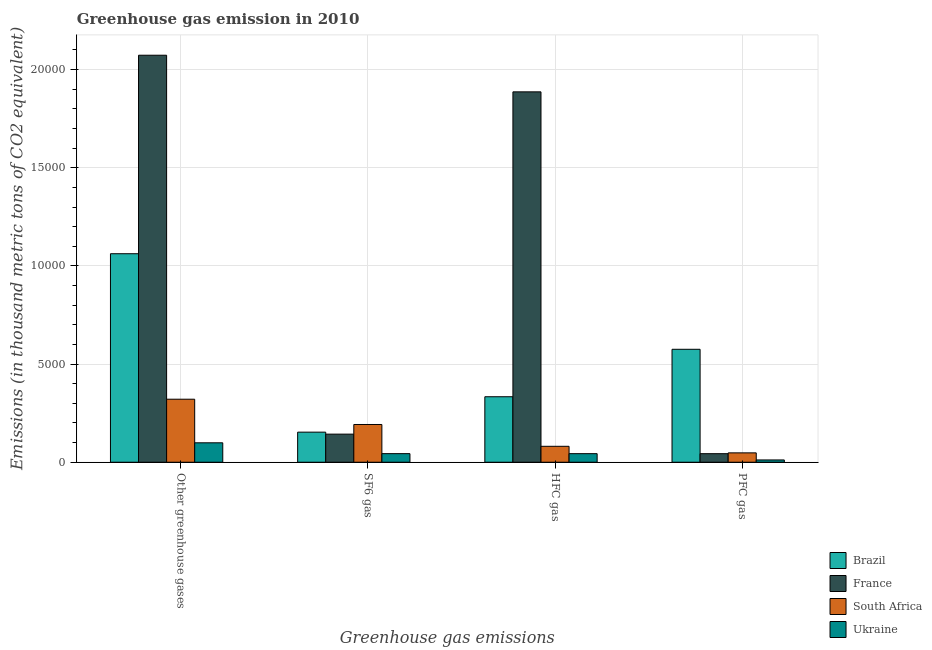How many different coloured bars are there?
Provide a succinct answer. 4. How many groups of bars are there?
Offer a very short reply. 4. Are the number of bars per tick equal to the number of legend labels?
Offer a terse response. Yes. How many bars are there on the 4th tick from the left?
Provide a succinct answer. 4. What is the label of the 2nd group of bars from the left?
Offer a terse response. SF6 gas. What is the emission of greenhouse gases in France?
Give a very brief answer. 2.07e+04. Across all countries, what is the maximum emission of sf6 gas?
Your response must be concise. 1922. Across all countries, what is the minimum emission of sf6 gas?
Your response must be concise. 437. In which country was the emission of hfc gas maximum?
Give a very brief answer. France. In which country was the emission of pfc gas minimum?
Keep it short and to the point. Ukraine. What is the total emission of greenhouse gases in the graph?
Offer a very short reply. 3.56e+04. What is the difference between the emission of pfc gas in France and that in South Africa?
Your answer should be compact. -42. What is the difference between the emission of sf6 gas in Ukraine and the emission of pfc gas in France?
Your response must be concise. 2. What is the average emission of pfc gas per country?
Make the answer very short. 1695.25. What is the difference between the emission of pfc gas and emission of hfc gas in France?
Ensure brevity in your answer.  -1.84e+04. In how many countries, is the emission of hfc gas greater than 17000 thousand metric tons?
Provide a succinct answer. 1. What is the ratio of the emission of hfc gas in France to that in Brazil?
Offer a very short reply. 5.66. Is the difference between the emission of pfc gas in Brazil and South Africa greater than the difference between the emission of greenhouse gases in Brazil and South Africa?
Make the answer very short. No. What is the difference between the highest and the second highest emission of hfc gas?
Your answer should be compact. 1.55e+04. What is the difference between the highest and the lowest emission of sf6 gas?
Give a very brief answer. 1485. In how many countries, is the emission of hfc gas greater than the average emission of hfc gas taken over all countries?
Ensure brevity in your answer.  1. Is the sum of the emission of sf6 gas in France and Brazil greater than the maximum emission of greenhouse gases across all countries?
Provide a short and direct response. No. Is it the case that in every country, the sum of the emission of sf6 gas and emission of pfc gas is greater than the sum of emission of hfc gas and emission of greenhouse gases?
Your answer should be compact. No. What does the 3rd bar from the left in Other greenhouse gases represents?
Give a very brief answer. South Africa. What is the difference between two consecutive major ticks on the Y-axis?
Make the answer very short. 5000. Does the graph contain grids?
Give a very brief answer. Yes. Where does the legend appear in the graph?
Give a very brief answer. Bottom right. How many legend labels are there?
Offer a very short reply. 4. What is the title of the graph?
Your response must be concise. Greenhouse gas emission in 2010. What is the label or title of the X-axis?
Ensure brevity in your answer.  Greenhouse gas emissions. What is the label or title of the Y-axis?
Provide a succinct answer. Emissions (in thousand metric tons of CO2 equivalent). What is the Emissions (in thousand metric tons of CO2 equivalent) of Brazil in Other greenhouse gases?
Give a very brief answer. 1.06e+04. What is the Emissions (in thousand metric tons of CO2 equivalent) in France in Other greenhouse gases?
Make the answer very short. 2.07e+04. What is the Emissions (in thousand metric tons of CO2 equivalent) of South Africa in Other greenhouse gases?
Ensure brevity in your answer.  3210. What is the Emissions (in thousand metric tons of CO2 equivalent) in Ukraine in Other greenhouse gases?
Offer a very short reply. 989. What is the Emissions (in thousand metric tons of CO2 equivalent) of Brazil in SF6 gas?
Provide a short and direct response. 1532. What is the Emissions (in thousand metric tons of CO2 equivalent) of France in SF6 gas?
Ensure brevity in your answer.  1431. What is the Emissions (in thousand metric tons of CO2 equivalent) in South Africa in SF6 gas?
Your answer should be very brief. 1922. What is the Emissions (in thousand metric tons of CO2 equivalent) in Ukraine in SF6 gas?
Give a very brief answer. 437. What is the Emissions (in thousand metric tons of CO2 equivalent) of Brazil in HFC gas?
Ensure brevity in your answer.  3336. What is the Emissions (in thousand metric tons of CO2 equivalent) of France in HFC gas?
Offer a terse response. 1.89e+04. What is the Emissions (in thousand metric tons of CO2 equivalent) of South Africa in HFC gas?
Offer a very short reply. 811. What is the Emissions (in thousand metric tons of CO2 equivalent) of Ukraine in HFC gas?
Give a very brief answer. 436. What is the Emissions (in thousand metric tons of CO2 equivalent) in Brazil in PFC gas?
Keep it short and to the point. 5753. What is the Emissions (in thousand metric tons of CO2 equivalent) of France in PFC gas?
Your answer should be very brief. 435. What is the Emissions (in thousand metric tons of CO2 equivalent) in South Africa in PFC gas?
Ensure brevity in your answer.  477. What is the Emissions (in thousand metric tons of CO2 equivalent) in Ukraine in PFC gas?
Provide a succinct answer. 116. Across all Greenhouse gas emissions, what is the maximum Emissions (in thousand metric tons of CO2 equivalent) of Brazil?
Keep it short and to the point. 1.06e+04. Across all Greenhouse gas emissions, what is the maximum Emissions (in thousand metric tons of CO2 equivalent) in France?
Your response must be concise. 2.07e+04. Across all Greenhouse gas emissions, what is the maximum Emissions (in thousand metric tons of CO2 equivalent) of South Africa?
Your response must be concise. 3210. Across all Greenhouse gas emissions, what is the maximum Emissions (in thousand metric tons of CO2 equivalent) of Ukraine?
Your answer should be compact. 989. Across all Greenhouse gas emissions, what is the minimum Emissions (in thousand metric tons of CO2 equivalent) in Brazil?
Give a very brief answer. 1532. Across all Greenhouse gas emissions, what is the minimum Emissions (in thousand metric tons of CO2 equivalent) in France?
Your response must be concise. 435. Across all Greenhouse gas emissions, what is the minimum Emissions (in thousand metric tons of CO2 equivalent) in South Africa?
Provide a short and direct response. 477. Across all Greenhouse gas emissions, what is the minimum Emissions (in thousand metric tons of CO2 equivalent) in Ukraine?
Your response must be concise. 116. What is the total Emissions (in thousand metric tons of CO2 equivalent) in Brazil in the graph?
Keep it short and to the point. 2.12e+04. What is the total Emissions (in thousand metric tons of CO2 equivalent) of France in the graph?
Provide a short and direct response. 4.15e+04. What is the total Emissions (in thousand metric tons of CO2 equivalent) in South Africa in the graph?
Your response must be concise. 6420. What is the total Emissions (in thousand metric tons of CO2 equivalent) in Ukraine in the graph?
Your response must be concise. 1978. What is the difference between the Emissions (in thousand metric tons of CO2 equivalent) in Brazil in Other greenhouse gases and that in SF6 gas?
Your answer should be compact. 9089. What is the difference between the Emissions (in thousand metric tons of CO2 equivalent) in France in Other greenhouse gases and that in SF6 gas?
Make the answer very short. 1.93e+04. What is the difference between the Emissions (in thousand metric tons of CO2 equivalent) in South Africa in Other greenhouse gases and that in SF6 gas?
Your answer should be compact. 1288. What is the difference between the Emissions (in thousand metric tons of CO2 equivalent) of Ukraine in Other greenhouse gases and that in SF6 gas?
Make the answer very short. 552. What is the difference between the Emissions (in thousand metric tons of CO2 equivalent) of Brazil in Other greenhouse gases and that in HFC gas?
Provide a succinct answer. 7285. What is the difference between the Emissions (in thousand metric tons of CO2 equivalent) of France in Other greenhouse gases and that in HFC gas?
Your response must be concise. 1866. What is the difference between the Emissions (in thousand metric tons of CO2 equivalent) in South Africa in Other greenhouse gases and that in HFC gas?
Give a very brief answer. 2399. What is the difference between the Emissions (in thousand metric tons of CO2 equivalent) in Ukraine in Other greenhouse gases and that in HFC gas?
Your answer should be compact. 553. What is the difference between the Emissions (in thousand metric tons of CO2 equivalent) in Brazil in Other greenhouse gases and that in PFC gas?
Your response must be concise. 4868. What is the difference between the Emissions (in thousand metric tons of CO2 equivalent) of France in Other greenhouse gases and that in PFC gas?
Keep it short and to the point. 2.03e+04. What is the difference between the Emissions (in thousand metric tons of CO2 equivalent) of South Africa in Other greenhouse gases and that in PFC gas?
Provide a succinct answer. 2733. What is the difference between the Emissions (in thousand metric tons of CO2 equivalent) of Ukraine in Other greenhouse gases and that in PFC gas?
Ensure brevity in your answer.  873. What is the difference between the Emissions (in thousand metric tons of CO2 equivalent) in Brazil in SF6 gas and that in HFC gas?
Offer a terse response. -1804. What is the difference between the Emissions (in thousand metric tons of CO2 equivalent) in France in SF6 gas and that in HFC gas?
Ensure brevity in your answer.  -1.74e+04. What is the difference between the Emissions (in thousand metric tons of CO2 equivalent) of South Africa in SF6 gas and that in HFC gas?
Your answer should be very brief. 1111. What is the difference between the Emissions (in thousand metric tons of CO2 equivalent) of Brazil in SF6 gas and that in PFC gas?
Your answer should be compact. -4221. What is the difference between the Emissions (in thousand metric tons of CO2 equivalent) in France in SF6 gas and that in PFC gas?
Your answer should be compact. 996. What is the difference between the Emissions (in thousand metric tons of CO2 equivalent) in South Africa in SF6 gas and that in PFC gas?
Make the answer very short. 1445. What is the difference between the Emissions (in thousand metric tons of CO2 equivalent) of Ukraine in SF6 gas and that in PFC gas?
Offer a very short reply. 321. What is the difference between the Emissions (in thousand metric tons of CO2 equivalent) in Brazil in HFC gas and that in PFC gas?
Offer a very short reply. -2417. What is the difference between the Emissions (in thousand metric tons of CO2 equivalent) in France in HFC gas and that in PFC gas?
Keep it short and to the point. 1.84e+04. What is the difference between the Emissions (in thousand metric tons of CO2 equivalent) of South Africa in HFC gas and that in PFC gas?
Ensure brevity in your answer.  334. What is the difference between the Emissions (in thousand metric tons of CO2 equivalent) of Ukraine in HFC gas and that in PFC gas?
Your answer should be compact. 320. What is the difference between the Emissions (in thousand metric tons of CO2 equivalent) of Brazil in Other greenhouse gases and the Emissions (in thousand metric tons of CO2 equivalent) of France in SF6 gas?
Give a very brief answer. 9190. What is the difference between the Emissions (in thousand metric tons of CO2 equivalent) of Brazil in Other greenhouse gases and the Emissions (in thousand metric tons of CO2 equivalent) of South Africa in SF6 gas?
Provide a succinct answer. 8699. What is the difference between the Emissions (in thousand metric tons of CO2 equivalent) in Brazil in Other greenhouse gases and the Emissions (in thousand metric tons of CO2 equivalent) in Ukraine in SF6 gas?
Give a very brief answer. 1.02e+04. What is the difference between the Emissions (in thousand metric tons of CO2 equivalent) of France in Other greenhouse gases and the Emissions (in thousand metric tons of CO2 equivalent) of South Africa in SF6 gas?
Ensure brevity in your answer.  1.88e+04. What is the difference between the Emissions (in thousand metric tons of CO2 equivalent) of France in Other greenhouse gases and the Emissions (in thousand metric tons of CO2 equivalent) of Ukraine in SF6 gas?
Offer a very short reply. 2.03e+04. What is the difference between the Emissions (in thousand metric tons of CO2 equivalent) in South Africa in Other greenhouse gases and the Emissions (in thousand metric tons of CO2 equivalent) in Ukraine in SF6 gas?
Ensure brevity in your answer.  2773. What is the difference between the Emissions (in thousand metric tons of CO2 equivalent) of Brazil in Other greenhouse gases and the Emissions (in thousand metric tons of CO2 equivalent) of France in HFC gas?
Offer a very short reply. -8246. What is the difference between the Emissions (in thousand metric tons of CO2 equivalent) in Brazil in Other greenhouse gases and the Emissions (in thousand metric tons of CO2 equivalent) in South Africa in HFC gas?
Make the answer very short. 9810. What is the difference between the Emissions (in thousand metric tons of CO2 equivalent) of Brazil in Other greenhouse gases and the Emissions (in thousand metric tons of CO2 equivalent) of Ukraine in HFC gas?
Offer a very short reply. 1.02e+04. What is the difference between the Emissions (in thousand metric tons of CO2 equivalent) in France in Other greenhouse gases and the Emissions (in thousand metric tons of CO2 equivalent) in South Africa in HFC gas?
Make the answer very short. 1.99e+04. What is the difference between the Emissions (in thousand metric tons of CO2 equivalent) of France in Other greenhouse gases and the Emissions (in thousand metric tons of CO2 equivalent) of Ukraine in HFC gas?
Keep it short and to the point. 2.03e+04. What is the difference between the Emissions (in thousand metric tons of CO2 equivalent) in South Africa in Other greenhouse gases and the Emissions (in thousand metric tons of CO2 equivalent) in Ukraine in HFC gas?
Your response must be concise. 2774. What is the difference between the Emissions (in thousand metric tons of CO2 equivalent) of Brazil in Other greenhouse gases and the Emissions (in thousand metric tons of CO2 equivalent) of France in PFC gas?
Offer a terse response. 1.02e+04. What is the difference between the Emissions (in thousand metric tons of CO2 equivalent) in Brazil in Other greenhouse gases and the Emissions (in thousand metric tons of CO2 equivalent) in South Africa in PFC gas?
Make the answer very short. 1.01e+04. What is the difference between the Emissions (in thousand metric tons of CO2 equivalent) in Brazil in Other greenhouse gases and the Emissions (in thousand metric tons of CO2 equivalent) in Ukraine in PFC gas?
Your answer should be compact. 1.05e+04. What is the difference between the Emissions (in thousand metric tons of CO2 equivalent) of France in Other greenhouse gases and the Emissions (in thousand metric tons of CO2 equivalent) of South Africa in PFC gas?
Provide a short and direct response. 2.03e+04. What is the difference between the Emissions (in thousand metric tons of CO2 equivalent) in France in Other greenhouse gases and the Emissions (in thousand metric tons of CO2 equivalent) in Ukraine in PFC gas?
Offer a terse response. 2.06e+04. What is the difference between the Emissions (in thousand metric tons of CO2 equivalent) in South Africa in Other greenhouse gases and the Emissions (in thousand metric tons of CO2 equivalent) in Ukraine in PFC gas?
Offer a very short reply. 3094. What is the difference between the Emissions (in thousand metric tons of CO2 equivalent) in Brazil in SF6 gas and the Emissions (in thousand metric tons of CO2 equivalent) in France in HFC gas?
Provide a succinct answer. -1.73e+04. What is the difference between the Emissions (in thousand metric tons of CO2 equivalent) in Brazil in SF6 gas and the Emissions (in thousand metric tons of CO2 equivalent) in South Africa in HFC gas?
Provide a short and direct response. 721. What is the difference between the Emissions (in thousand metric tons of CO2 equivalent) of Brazil in SF6 gas and the Emissions (in thousand metric tons of CO2 equivalent) of Ukraine in HFC gas?
Your response must be concise. 1096. What is the difference between the Emissions (in thousand metric tons of CO2 equivalent) of France in SF6 gas and the Emissions (in thousand metric tons of CO2 equivalent) of South Africa in HFC gas?
Provide a short and direct response. 620. What is the difference between the Emissions (in thousand metric tons of CO2 equivalent) of France in SF6 gas and the Emissions (in thousand metric tons of CO2 equivalent) of Ukraine in HFC gas?
Your answer should be compact. 995. What is the difference between the Emissions (in thousand metric tons of CO2 equivalent) of South Africa in SF6 gas and the Emissions (in thousand metric tons of CO2 equivalent) of Ukraine in HFC gas?
Your response must be concise. 1486. What is the difference between the Emissions (in thousand metric tons of CO2 equivalent) in Brazil in SF6 gas and the Emissions (in thousand metric tons of CO2 equivalent) in France in PFC gas?
Offer a terse response. 1097. What is the difference between the Emissions (in thousand metric tons of CO2 equivalent) of Brazil in SF6 gas and the Emissions (in thousand metric tons of CO2 equivalent) of South Africa in PFC gas?
Offer a very short reply. 1055. What is the difference between the Emissions (in thousand metric tons of CO2 equivalent) of Brazil in SF6 gas and the Emissions (in thousand metric tons of CO2 equivalent) of Ukraine in PFC gas?
Give a very brief answer. 1416. What is the difference between the Emissions (in thousand metric tons of CO2 equivalent) of France in SF6 gas and the Emissions (in thousand metric tons of CO2 equivalent) of South Africa in PFC gas?
Keep it short and to the point. 954. What is the difference between the Emissions (in thousand metric tons of CO2 equivalent) of France in SF6 gas and the Emissions (in thousand metric tons of CO2 equivalent) of Ukraine in PFC gas?
Provide a succinct answer. 1315. What is the difference between the Emissions (in thousand metric tons of CO2 equivalent) in South Africa in SF6 gas and the Emissions (in thousand metric tons of CO2 equivalent) in Ukraine in PFC gas?
Offer a very short reply. 1806. What is the difference between the Emissions (in thousand metric tons of CO2 equivalent) of Brazil in HFC gas and the Emissions (in thousand metric tons of CO2 equivalent) of France in PFC gas?
Make the answer very short. 2901. What is the difference between the Emissions (in thousand metric tons of CO2 equivalent) in Brazil in HFC gas and the Emissions (in thousand metric tons of CO2 equivalent) in South Africa in PFC gas?
Offer a very short reply. 2859. What is the difference between the Emissions (in thousand metric tons of CO2 equivalent) in Brazil in HFC gas and the Emissions (in thousand metric tons of CO2 equivalent) in Ukraine in PFC gas?
Give a very brief answer. 3220. What is the difference between the Emissions (in thousand metric tons of CO2 equivalent) in France in HFC gas and the Emissions (in thousand metric tons of CO2 equivalent) in South Africa in PFC gas?
Keep it short and to the point. 1.84e+04. What is the difference between the Emissions (in thousand metric tons of CO2 equivalent) of France in HFC gas and the Emissions (in thousand metric tons of CO2 equivalent) of Ukraine in PFC gas?
Your response must be concise. 1.88e+04. What is the difference between the Emissions (in thousand metric tons of CO2 equivalent) in South Africa in HFC gas and the Emissions (in thousand metric tons of CO2 equivalent) in Ukraine in PFC gas?
Provide a short and direct response. 695. What is the average Emissions (in thousand metric tons of CO2 equivalent) of Brazil per Greenhouse gas emissions?
Make the answer very short. 5310.5. What is the average Emissions (in thousand metric tons of CO2 equivalent) in France per Greenhouse gas emissions?
Your answer should be compact. 1.04e+04. What is the average Emissions (in thousand metric tons of CO2 equivalent) in South Africa per Greenhouse gas emissions?
Your response must be concise. 1605. What is the average Emissions (in thousand metric tons of CO2 equivalent) of Ukraine per Greenhouse gas emissions?
Your response must be concise. 494.5. What is the difference between the Emissions (in thousand metric tons of CO2 equivalent) in Brazil and Emissions (in thousand metric tons of CO2 equivalent) in France in Other greenhouse gases?
Make the answer very short. -1.01e+04. What is the difference between the Emissions (in thousand metric tons of CO2 equivalent) of Brazil and Emissions (in thousand metric tons of CO2 equivalent) of South Africa in Other greenhouse gases?
Ensure brevity in your answer.  7411. What is the difference between the Emissions (in thousand metric tons of CO2 equivalent) in Brazil and Emissions (in thousand metric tons of CO2 equivalent) in Ukraine in Other greenhouse gases?
Offer a terse response. 9632. What is the difference between the Emissions (in thousand metric tons of CO2 equivalent) in France and Emissions (in thousand metric tons of CO2 equivalent) in South Africa in Other greenhouse gases?
Give a very brief answer. 1.75e+04. What is the difference between the Emissions (in thousand metric tons of CO2 equivalent) in France and Emissions (in thousand metric tons of CO2 equivalent) in Ukraine in Other greenhouse gases?
Offer a terse response. 1.97e+04. What is the difference between the Emissions (in thousand metric tons of CO2 equivalent) of South Africa and Emissions (in thousand metric tons of CO2 equivalent) of Ukraine in Other greenhouse gases?
Give a very brief answer. 2221. What is the difference between the Emissions (in thousand metric tons of CO2 equivalent) in Brazil and Emissions (in thousand metric tons of CO2 equivalent) in France in SF6 gas?
Provide a short and direct response. 101. What is the difference between the Emissions (in thousand metric tons of CO2 equivalent) in Brazil and Emissions (in thousand metric tons of CO2 equivalent) in South Africa in SF6 gas?
Provide a succinct answer. -390. What is the difference between the Emissions (in thousand metric tons of CO2 equivalent) of Brazil and Emissions (in thousand metric tons of CO2 equivalent) of Ukraine in SF6 gas?
Ensure brevity in your answer.  1095. What is the difference between the Emissions (in thousand metric tons of CO2 equivalent) of France and Emissions (in thousand metric tons of CO2 equivalent) of South Africa in SF6 gas?
Provide a short and direct response. -491. What is the difference between the Emissions (in thousand metric tons of CO2 equivalent) of France and Emissions (in thousand metric tons of CO2 equivalent) of Ukraine in SF6 gas?
Give a very brief answer. 994. What is the difference between the Emissions (in thousand metric tons of CO2 equivalent) of South Africa and Emissions (in thousand metric tons of CO2 equivalent) of Ukraine in SF6 gas?
Provide a succinct answer. 1485. What is the difference between the Emissions (in thousand metric tons of CO2 equivalent) in Brazil and Emissions (in thousand metric tons of CO2 equivalent) in France in HFC gas?
Your answer should be very brief. -1.55e+04. What is the difference between the Emissions (in thousand metric tons of CO2 equivalent) of Brazil and Emissions (in thousand metric tons of CO2 equivalent) of South Africa in HFC gas?
Provide a succinct answer. 2525. What is the difference between the Emissions (in thousand metric tons of CO2 equivalent) of Brazil and Emissions (in thousand metric tons of CO2 equivalent) of Ukraine in HFC gas?
Make the answer very short. 2900. What is the difference between the Emissions (in thousand metric tons of CO2 equivalent) of France and Emissions (in thousand metric tons of CO2 equivalent) of South Africa in HFC gas?
Make the answer very short. 1.81e+04. What is the difference between the Emissions (in thousand metric tons of CO2 equivalent) of France and Emissions (in thousand metric tons of CO2 equivalent) of Ukraine in HFC gas?
Offer a very short reply. 1.84e+04. What is the difference between the Emissions (in thousand metric tons of CO2 equivalent) in South Africa and Emissions (in thousand metric tons of CO2 equivalent) in Ukraine in HFC gas?
Your answer should be very brief. 375. What is the difference between the Emissions (in thousand metric tons of CO2 equivalent) of Brazil and Emissions (in thousand metric tons of CO2 equivalent) of France in PFC gas?
Provide a succinct answer. 5318. What is the difference between the Emissions (in thousand metric tons of CO2 equivalent) of Brazil and Emissions (in thousand metric tons of CO2 equivalent) of South Africa in PFC gas?
Your response must be concise. 5276. What is the difference between the Emissions (in thousand metric tons of CO2 equivalent) in Brazil and Emissions (in thousand metric tons of CO2 equivalent) in Ukraine in PFC gas?
Ensure brevity in your answer.  5637. What is the difference between the Emissions (in thousand metric tons of CO2 equivalent) in France and Emissions (in thousand metric tons of CO2 equivalent) in South Africa in PFC gas?
Give a very brief answer. -42. What is the difference between the Emissions (in thousand metric tons of CO2 equivalent) of France and Emissions (in thousand metric tons of CO2 equivalent) of Ukraine in PFC gas?
Offer a terse response. 319. What is the difference between the Emissions (in thousand metric tons of CO2 equivalent) in South Africa and Emissions (in thousand metric tons of CO2 equivalent) in Ukraine in PFC gas?
Your answer should be compact. 361. What is the ratio of the Emissions (in thousand metric tons of CO2 equivalent) of Brazil in Other greenhouse gases to that in SF6 gas?
Provide a short and direct response. 6.93. What is the ratio of the Emissions (in thousand metric tons of CO2 equivalent) of France in Other greenhouse gases to that in SF6 gas?
Provide a succinct answer. 14.49. What is the ratio of the Emissions (in thousand metric tons of CO2 equivalent) in South Africa in Other greenhouse gases to that in SF6 gas?
Ensure brevity in your answer.  1.67. What is the ratio of the Emissions (in thousand metric tons of CO2 equivalent) of Ukraine in Other greenhouse gases to that in SF6 gas?
Make the answer very short. 2.26. What is the ratio of the Emissions (in thousand metric tons of CO2 equivalent) of Brazil in Other greenhouse gases to that in HFC gas?
Your answer should be very brief. 3.18. What is the ratio of the Emissions (in thousand metric tons of CO2 equivalent) in France in Other greenhouse gases to that in HFC gas?
Offer a terse response. 1.1. What is the ratio of the Emissions (in thousand metric tons of CO2 equivalent) in South Africa in Other greenhouse gases to that in HFC gas?
Make the answer very short. 3.96. What is the ratio of the Emissions (in thousand metric tons of CO2 equivalent) of Ukraine in Other greenhouse gases to that in HFC gas?
Your answer should be very brief. 2.27. What is the ratio of the Emissions (in thousand metric tons of CO2 equivalent) of Brazil in Other greenhouse gases to that in PFC gas?
Make the answer very short. 1.85. What is the ratio of the Emissions (in thousand metric tons of CO2 equivalent) of France in Other greenhouse gases to that in PFC gas?
Your answer should be compact. 47.66. What is the ratio of the Emissions (in thousand metric tons of CO2 equivalent) in South Africa in Other greenhouse gases to that in PFC gas?
Offer a very short reply. 6.73. What is the ratio of the Emissions (in thousand metric tons of CO2 equivalent) of Ukraine in Other greenhouse gases to that in PFC gas?
Provide a short and direct response. 8.53. What is the ratio of the Emissions (in thousand metric tons of CO2 equivalent) of Brazil in SF6 gas to that in HFC gas?
Keep it short and to the point. 0.46. What is the ratio of the Emissions (in thousand metric tons of CO2 equivalent) in France in SF6 gas to that in HFC gas?
Your answer should be very brief. 0.08. What is the ratio of the Emissions (in thousand metric tons of CO2 equivalent) in South Africa in SF6 gas to that in HFC gas?
Your answer should be very brief. 2.37. What is the ratio of the Emissions (in thousand metric tons of CO2 equivalent) of Ukraine in SF6 gas to that in HFC gas?
Make the answer very short. 1. What is the ratio of the Emissions (in thousand metric tons of CO2 equivalent) in Brazil in SF6 gas to that in PFC gas?
Keep it short and to the point. 0.27. What is the ratio of the Emissions (in thousand metric tons of CO2 equivalent) in France in SF6 gas to that in PFC gas?
Your response must be concise. 3.29. What is the ratio of the Emissions (in thousand metric tons of CO2 equivalent) in South Africa in SF6 gas to that in PFC gas?
Make the answer very short. 4.03. What is the ratio of the Emissions (in thousand metric tons of CO2 equivalent) in Ukraine in SF6 gas to that in PFC gas?
Keep it short and to the point. 3.77. What is the ratio of the Emissions (in thousand metric tons of CO2 equivalent) of Brazil in HFC gas to that in PFC gas?
Make the answer very short. 0.58. What is the ratio of the Emissions (in thousand metric tons of CO2 equivalent) in France in HFC gas to that in PFC gas?
Your answer should be very brief. 43.37. What is the ratio of the Emissions (in thousand metric tons of CO2 equivalent) in South Africa in HFC gas to that in PFC gas?
Offer a terse response. 1.7. What is the ratio of the Emissions (in thousand metric tons of CO2 equivalent) of Ukraine in HFC gas to that in PFC gas?
Offer a terse response. 3.76. What is the difference between the highest and the second highest Emissions (in thousand metric tons of CO2 equivalent) of Brazil?
Give a very brief answer. 4868. What is the difference between the highest and the second highest Emissions (in thousand metric tons of CO2 equivalent) of France?
Make the answer very short. 1866. What is the difference between the highest and the second highest Emissions (in thousand metric tons of CO2 equivalent) of South Africa?
Offer a very short reply. 1288. What is the difference between the highest and the second highest Emissions (in thousand metric tons of CO2 equivalent) of Ukraine?
Ensure brevity in your answer.  552. What is the difference between the highest and the lowest Emissions (in thousand metric tons of CO2 equivalent) in Brazil?
Ensure brevity in your answer.  9089. What is the difference between the highest and the lowest Emissions (in thousand metric tons of CO2 equivalent) in France?
Offer a very short reply. 2.03e+04. What is the difference between the highest and the lowest Emissions (in thousand metric tons of CO2 equivalent) of South Africa?
Keep it short and to the point. 2733. What is the difference between the highest and the lowest Emissions (in thousand metric tons of CO2 equivalent) in Ukraine?
Offer a very short reply. 873. 